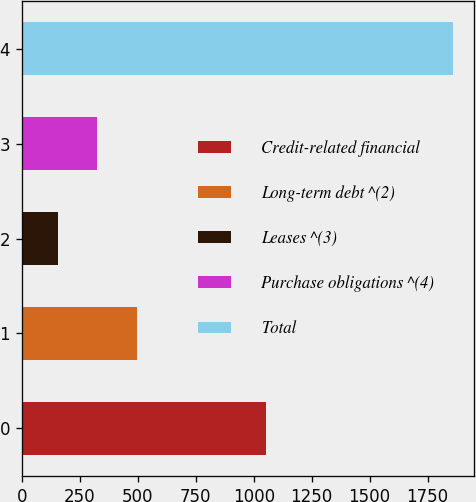Convert chart to OTSL. <chart><loc_0><loc_0><loc_500><loc_500><bar_chart><fcel>Credit-related financial<fcel>Long-term debt ^(2)<fcel>Leases ^(3)<fcel>Purchase obligations ^(4)<fcel>Total<nl><fcel>1054<fcel>496.4<fcel>156<fcel>326.2<fcel>1858<nl></chart> 